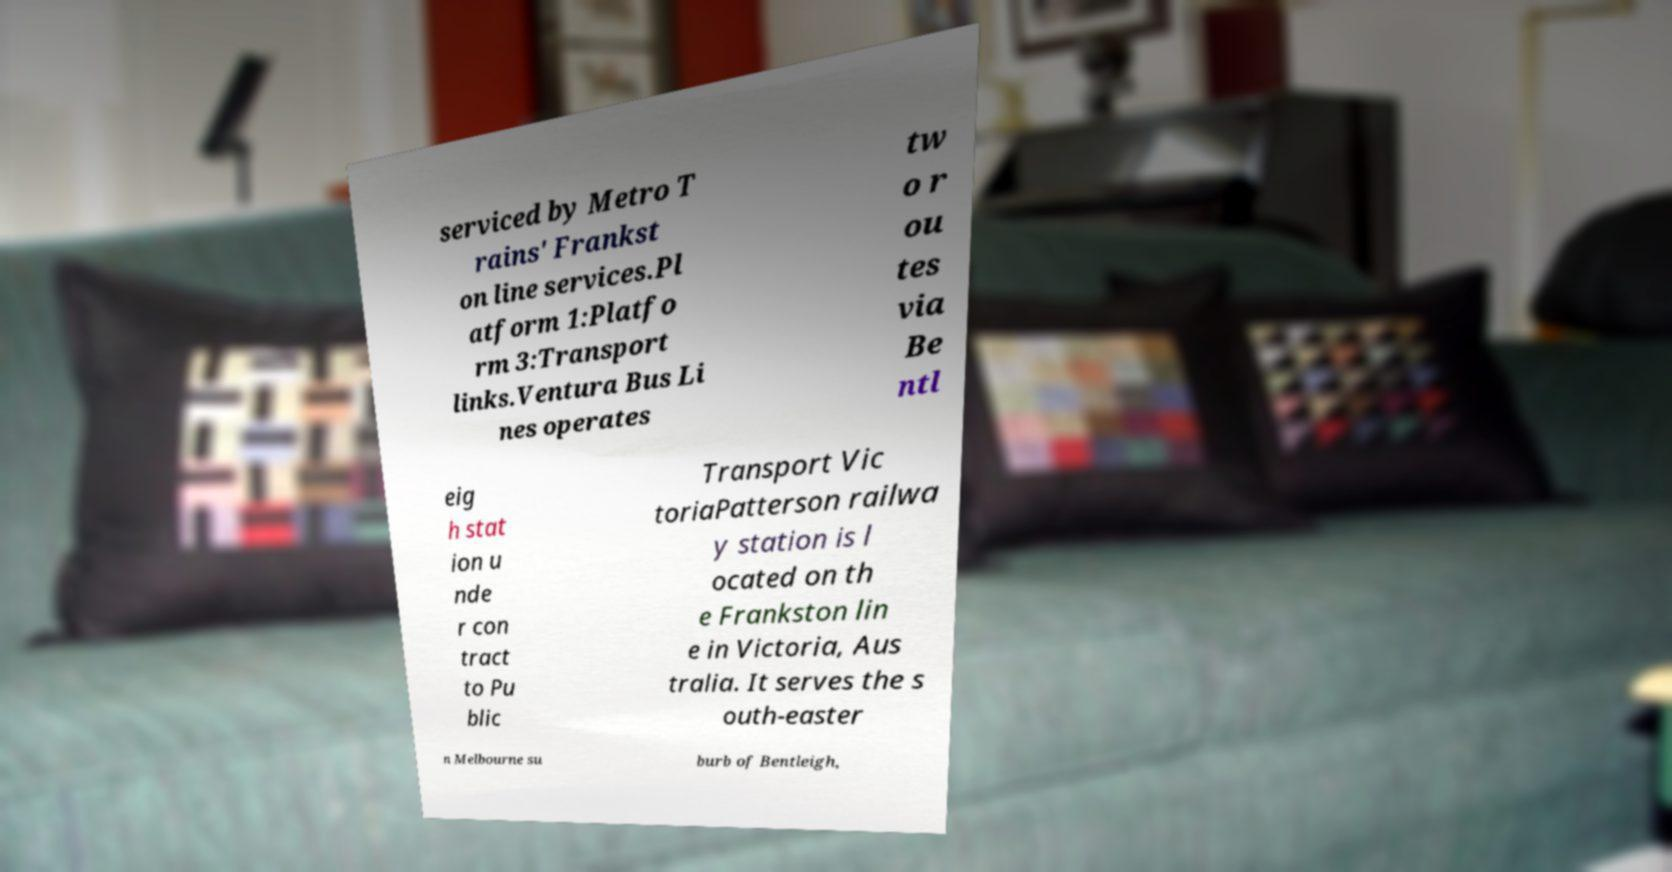There's text embedded in this image that I need extracted. Can you transcribe it verbatim? serviced by Metro T rains' Frankst on line services.Pl atform 1:Platfo rm 3:Transport links.Ventura Bus Li nes operates tw o r ou tes via Be ntl eig h stat ion u nde r con tract to Pu blic Transport Vic toriaPatterson railwa y station is l ocated on th e Frankston lin e in Victoria, Aus tralia. It serves the s outh-easter n Melbourne su burb of Bentleigh, 